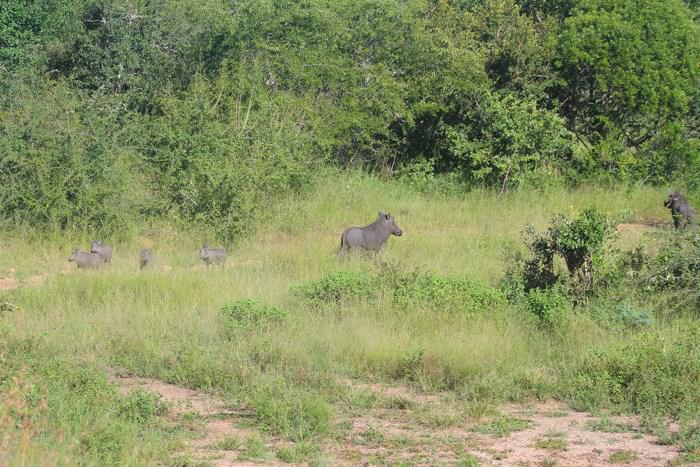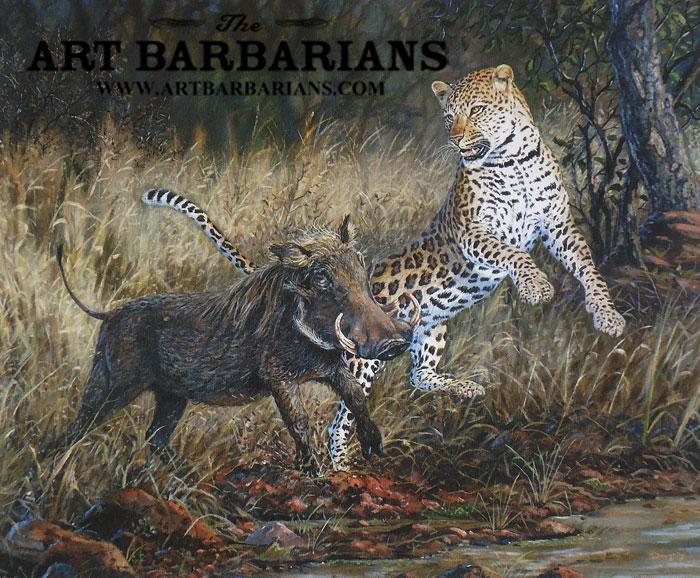The first image is the image on the left, the second image is the image on the right. Given the left and right images, does the statement "There is a feline in one of the images." hold true? Answer yes or no. Yes. The first image is the image on the left, the second image is the image on the right. Assess this claim about the two images: "An image shows warthog on the left and spotted cat on the right.". Correct or not? Answer yes or no. Yes. 